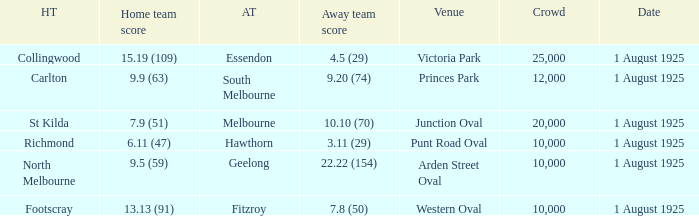Could you parse the entire table? {'header': ['HT', 'Home team score', 'AT', 'Away team score', 'Venue', 'Crowd', 'Date'], 'rows': [['Collingwood', '15.19 (109)', 'Essendon', '4.5 (29)', 'Victoria Park', '25,000', '1 August 1925'], ['Carlton', '9.9 (63)', 'South Melbourne', '9.20 (74)', 'Princes Park', '12,000', '1 August 1925'], ['St Kilda', '7.9 (51)', 'Melbourne', '10.10 (70)', 'Junction Oval', '20,000', '1 August 1925'], ['Richmond', '6.11 (47)', 'Hawthorn', '3.11 (29)', 'Punt Road Oval', '10,000', '1 August 1925'], ['North Melbourne', '9.5 (59)', 'Geelong', '22.22 (154)', 'Arden Street Oval', '10,000', '1 August 1925'], ['Footscray', '13.13 (91)', 'Fitzroy', '7.8 (50)', 'Western Oval', '10,000', '1 August 1925']]} Which team plays home at Princes Park? Carlton. 